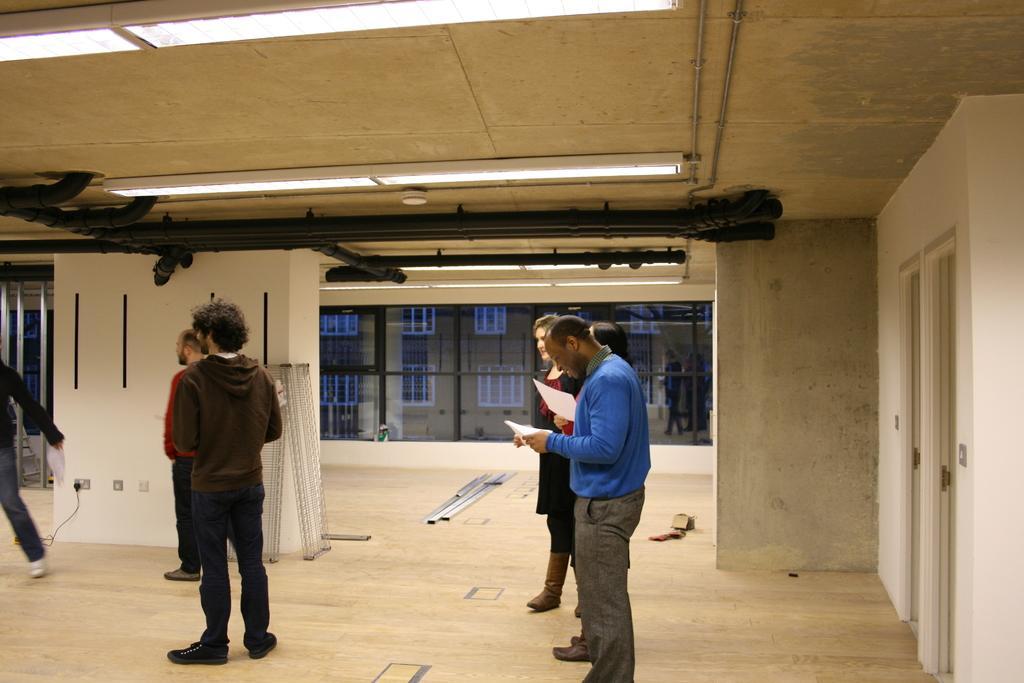In one or two sentences, can you explain what this image depicts? In the picture I can see few people standing on the floor. I can see two persons on the right side holding the papers. I can see the pipelines and lights on the roof. In the background, I can see the building and glass windows. 